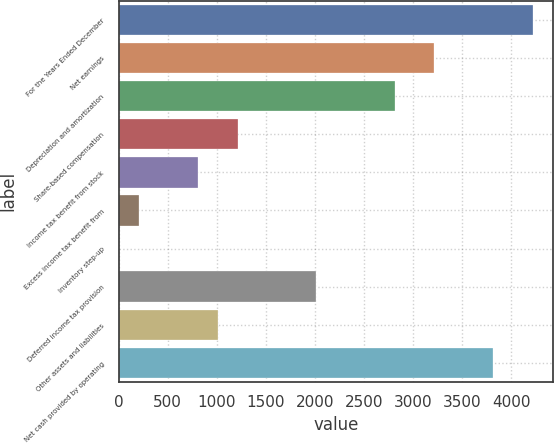<chart> <loc_0><loc_0><loc_500><loc_500><bar_chart><fcel>For the Years Ended December<fcel>Net earnings<fcel>Depreciation and amortization<fcel>Share-based compensation<fcel>Income tax benefit from stock<fcel>Excess income tax benefit from<fcel>Inventory step-up<fcel>Deferred income tax provision<fcel>Other assets and liabilities<fcel>Net cash provided by operating<nl><fcel>4218.5<fcel>3216<fcel>2815<fcel>1211<fcel>810<fcel>208.5<fcel>8<fcel>2013<fcel>1010.5<fcel>3817.5<nl></chart> 